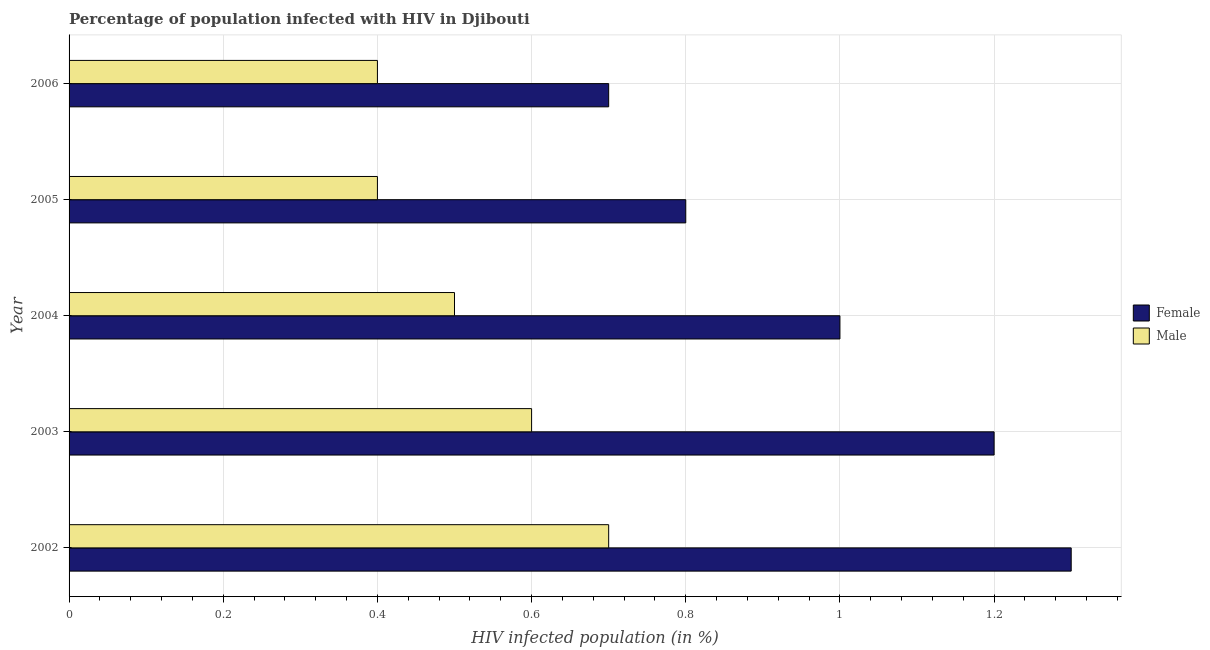How many different coloured bars are there?
Offer a very short reply. 2. How many groups of bars are there?
Offer a very short reply. 5. Are the number of bars per tick equal to the number of legend labels?
Keep it short and to the point. Yes. How many bars are there on the 5th tick from the top?
Keep it short and to the point. 2. What is the label of the 4th group of bars from the top?
Your response must be concise. 2003. In which year was the percentage of females who are infected with hiv minimum?
Provide a short and direct response. 2006. What is the total percentage of females who are infected with hiv in the graph?
Provide a short and direct response. 5. What is the average percentage of males who are infected with hiv per year?
Give a very brief answer. 0.52. Is the percentage of females who are infected with hiv in 2003 less than that in 2006?
Keep it short and to the point. No. Is the difference between the percentage of males who are infected with hiv in 2003 and 2006 greater than the difference between the percentage of females who are infected with hiv in 2003 and 2006?
Your answer should be compact. No. What is the difference between the highest and the second highest percentage of females who are infected with hiv?
Your answer should be compact. 0.1. What is the difference between the highest and the lowest percentage of females who are infected with hiv?
Provide a succinct answer. 0.6. In how many years, is the percentage of females who are infected with hiv greater than the average percentage of females who are infected with hiv taken over all years?
Your response must be concise. 2. What does the 2nd bar from the top in 2004 represents?
Provide a succinct answer. Female. What does the 2nd bar from the bottom in 2004 represents?
Ensure brevity in your answer.  Male. How many bars are there?
Provide a succinct answer. 10. Are all the bars in the graph horizontal?
Offer a terse response. Yes. What is the difference between two consecutive major ticks on the X-axis?
Your response must be concise. 0.2. Are the values on the major ticks of X-axis written in scientific E-notation?
Give a very brief answer. No. Does the graph contain any zero values?
Provide a short and direct response. No. Does the graph contain grids?
Offer a terse response. Yes. How many legend labels are there?
Offer a very short reply. 2. How are the legend labels stacked?
Provide a short and direct response. Vertical. What is the title of the graph?
Your response must be concise. Percentage of population infected with HIV in Djibouti. Does "Urban Population" appear as one of the legend labels in the graph?
Your answer should be very brief. No. What is the label or title of the X-axis?
Give a very brief answer. HIV infected population (in %). What is the label or title of the Y-axis?
Make the answer very short. Year. What is the HIV infected population (in %) of Female in 2002?
Offer a very short reply. 1.3. What is the HIV infected population (in %) in Male in 2002?
Provide a short and direct response. 0.7. What is the HIV infected population (in %) of Female in 2003?
Make the answer very short. 1.2. What is the HIV infected population (in %) in Male in 2003?
Provide a succinct answer. 0.6. What is the HIV infected population (in %) in Female in 2004?
Provide a succinct answer. 1. What is the HIV infected population (in %) in Female in 2006?
Offer a terse response. 0.7. Across all years, what is the maximum HIV infected population (in %) of Female?
Give a very brief answer. 1.3. Across all years, what is the maximum HIV infected population (in %) of Male?
Your response must be concise. 0.7. Across all years, what is the minimum HIV infected population (in %) in Female?
Ensure brevity in your answer.  0.7. Across all years, what is the minimum HIV infected population (in %) in Male?
Ensure brevity in your answer.  0.4. What is the total HIV infected population (in %) in Female in the graph?
Your answer should be very brief. 5. What is the difference between the HIV infected population (in %) of Male in 2002 and that in 2003?
Your answer should be compact. 0.1. What is the difference between the HIV infected population (in %) of Female in 2002 and that in 2004?
Offer a very short reply. 0.3. What is the difference between the HIV infected population (in %) in Female in 2002 and that in 2005?
Give a very brief answer. 0.5. What is the difference between the HIV infected population (in %) of Male in 2002 and that in 2005?
Offer a terse response. 0.3. What is the difference between the HIV infected population (in %) in Male in 2003 and that in 2004?
Provide a short and direct response. 0.1. What is the difference between the HIV infected population (in %) in Male in 2003 and that in 2005?
Provide a short and direct response. 0.2. What is the difference between the HIV infected population (in %) of Female in 2003 and that in 2006?
Give a very brief answer. 0.5. What is the difference between the HIV infected population (in %) of Male in 2003 and that in 2006?
Ensure brevity in your answer.  0.2. What is the difference between the HIV infected population (in %) in Female in 2004 and that in 2005?
Your answer should be very brief. 0.2. What is the difference between the HIV infected population (in %) in Male in 2004 and that in 2006?
Ensure brevity in your answer.  0.1. What is the difference between the HIV infected population (in %) of Female in 2005 and that in 2006?
Give a very brief answer. 0.1. What is the difference between the HIV infected population (in %) of Male in 2005 and that in 2006?
Provide a succinct answer. 0. What is the difference between the HIV infected population (in %) in Female in 2002 and the HIV infected population (in %) in Male in 2004?
Give a very brief answer. 0.8. What is the difference between the HIV infected population (in %) of Female in 2003 and the HIV infected population (in %) of Male in 2004?
Your answer should be compact. 0.7. What is the difference between the HIV infected population (in %) in Female in 2003 and the HIV infected population (in %) in Male in 2006?
Offer a terse response. 0.8. What is the difference between the HIV infected population (in %) in Female in 2004 and the HIV infected population (in %) in Male in 2006?
Make the answer very short. 0.6. What is the difference between the HIV infected population (in %) in Female in 2005 and the HIV infected population (in %) in Male in 2006?
Provide a short and direct response. 0.4. What is the average HIV infected population (in %) of Female per year?
Your answer should be very brief. 1. What is the average HIV infected population (in %) of Male per year?
Your answer should be very brief. 0.52. In the year 2004, what is the difference between the HIV infected population (in %) of Female and HIV infected population (in %) of Male?
Offer a terse response. 0.5. What is the ratio of the HIV infected population (in %) in Male in 2002 to that in 2003?
Ensure brevity in your answer.  1.17. What is the ratio of the HIV infected population (in %) in Female in 2002 to that in 2004?
Ensure brevity in your answer.  1.3. What is the ratio of the HIV infected population (in %) in Male in 2002 to that in 2004?
Keep it short and to the point. 1.4. What is the ratio of the HIV infected population (in %) in Female in 2002 to that in 2005?
Make the answer very short. 1.62. What is the ratio of the HIV infected population (in %) in Male in 2002 to that in 2005?
Provide a succinct answer. 1.75. What is the ratio of the HIV infected population (in %) in Female in 2002 to that in 2006?
Provide a succinct answer. 1.86. What is the ratio of the HIV infected population (in %) of Female in 2003 to that in 2004?
Your answer should be compact. 1.2. What is the ratio of the HIV infected population (in %) of Male in 2003 to that in 2004?
Make the answer very short. 1.2. What is the ratio of the HIV infected population (in %) in Female in 2003 to that in 2006?
Your answer should be very brief. 1.71. What is the ratio of the HIV infected population (in %) of Female in 2004 to that in 2006?
Your response must be concise. 1.43. What is the ratio of the HIV infected population (in %) of Male in 2004 to that in 2006?
Your answer should be very brief. 1.25. What is the ratio of the HIV infected population (in %) of Female in 2005 to that in 2006?
Your answer should be compact. 1.14. What is the ratio of the HIV infected population (in %) in Male in 2005 to that in 2006?
Your answer should be very brief. 1. What is the difference between the highest and the second highest HIV infected population (in %) in Female?
Provide a short and direct response. 0.1. What is the difference between the highest and the second highest HIV infected population (in %) in Male?
Your answer should be compact. 0.1. What is the difference between the highest and the lowest HIV infected population (in %) of Female?
Your answer should be compact. 0.6. What is the difference between the highest and the lowest HIV infected population (in %) in Male?
Ensure brevity in your answer.  0.3. 